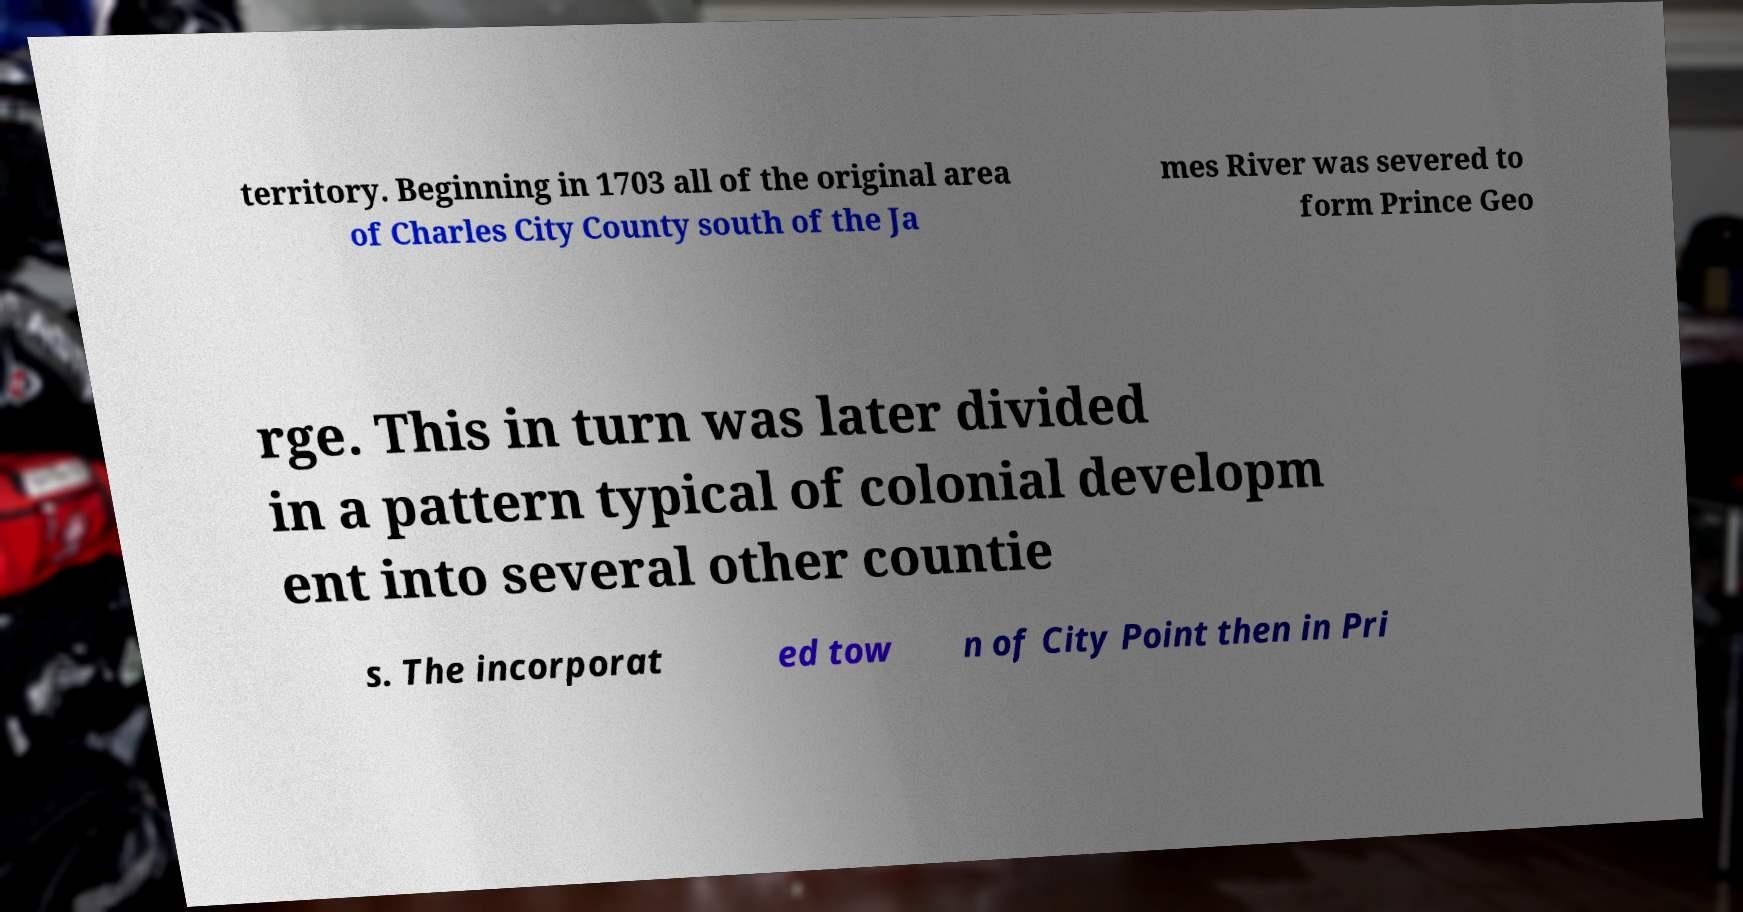For documentation purposes, I need the text within this image transcribed. Could you provide that? territory. Beginning in 1703 all of the original area of Charles City County south of the Ja mes River was severed to form Prince Geo rge. This in turn was later divided in a pattern typical of colonial developm ent into several other countie s. The incorporat ed tow n of City Point then in Pri 